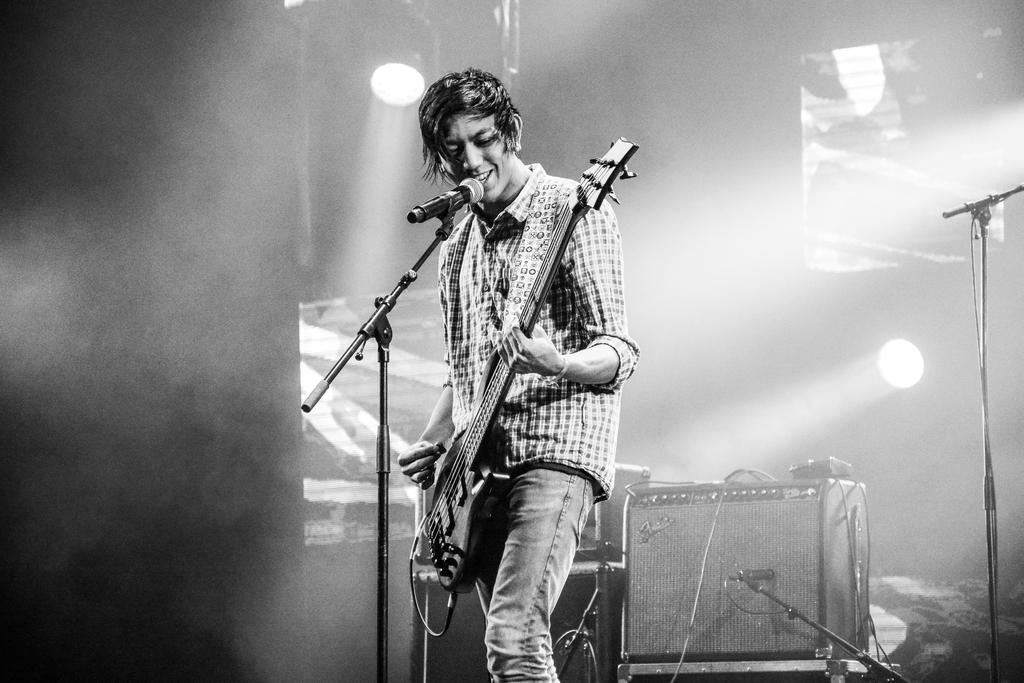What is the man in the image doing? The man is playing a guitar and singing. What instrument is the man using in the image? The man is playing a guitar. What can be seen in the background of the image? There is a microphone and lights in the background. How does the man attract the attention of the stranger in the image? There is no stranger present in the image, so it is not possible to determine how the man attracts their attention. 